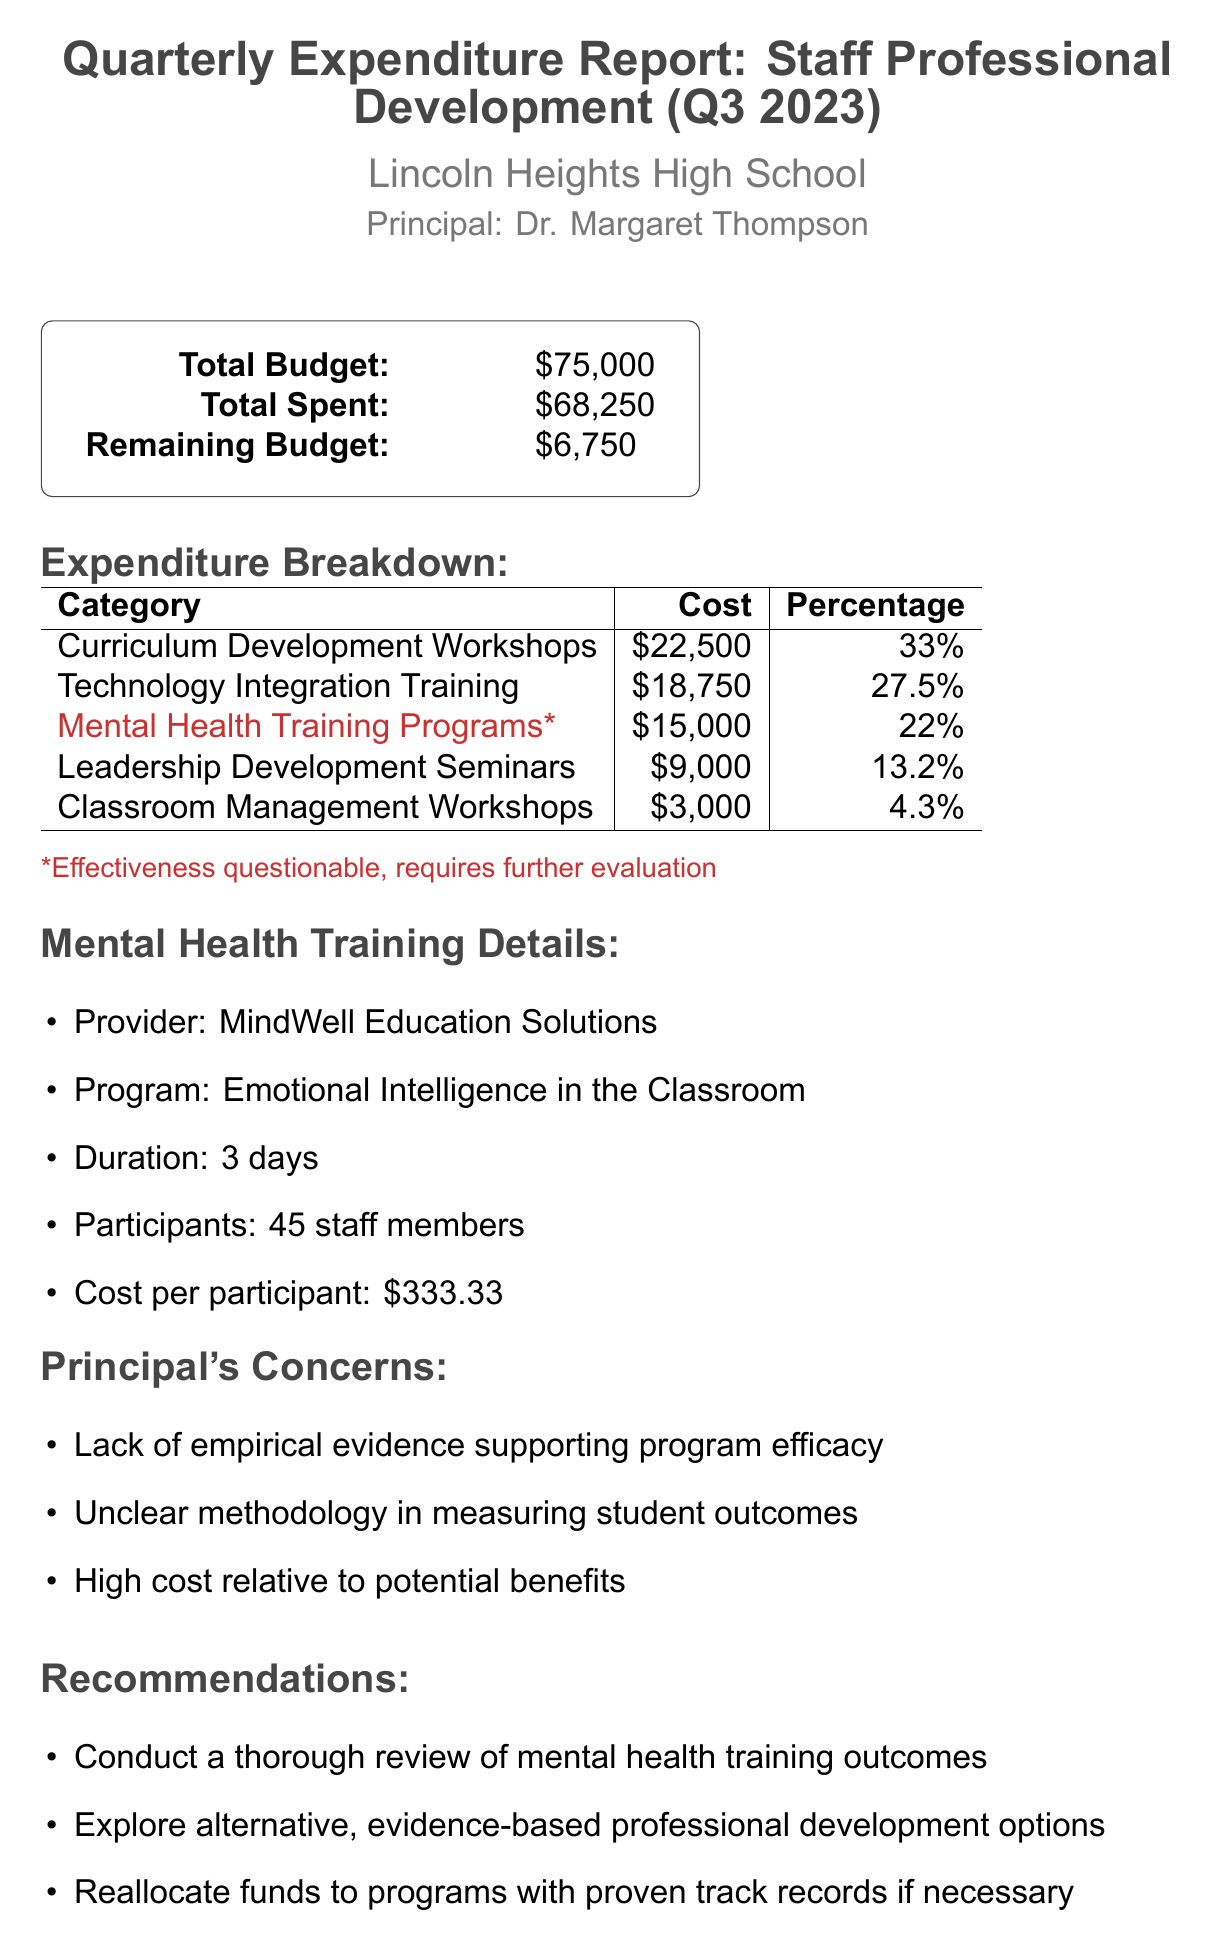What is the total budget? The total budget is the amount allocated for staff professional development, which is clearly stated in the document.
Answer: $75,000 How much was spent on Mental Health Training Programs? The document specifically lists the cost associated with Mental Health Training Programs in the expenditure breakdown section.
Answer: $15,000 What percentage of the total budget was spent on Technology Integration Training? The percentage is provided in the expenditure breakdown, showing how much of the total budget was allocated to this category.
Answer: 27.5% Who is the provider of the mental health training program? The provider's name is listed under Mental Health Training Details, indicating who conducted the training program.
Answer: MindWell Education Solutions What is one reason for the principal's concerns about the mental health training program? The principal's specific concerns are detailed in a list, showing critical viewpoints regarding the training program’s effectiveness.
Answer: Lack of empirical evidence supporting program efficacy How many staff members participated in the mental health training program? The document states the number of participants under the details of the mental health training program.
Answer: 45 staff members What is the remaining budget after expenditures? The remaining budget is a calculated figure based on the total budget minus the amount spent, as shown in the report.
Answer: $6,750 What recommendation is made regarding mental health training outcomes? The recommendations section advises on a specific course of action related to mental health training outcomes.
Answer: Conduct a thorough review of mental health training outcomes What is the duration of the mental health training program? The document specifies the length of the training program in the details section.
Answer: 3 days 